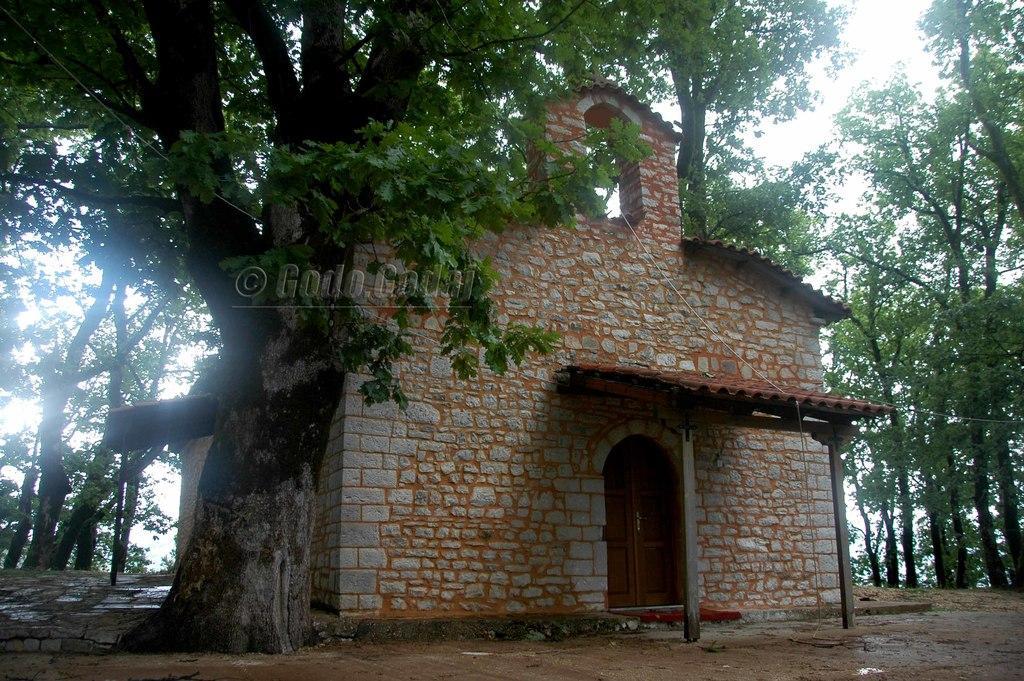Please provide a concise description of this image. In the picture I can see the stone house, trees, a board and the sky in the background. Here I can see the watermark in the center of the image. 